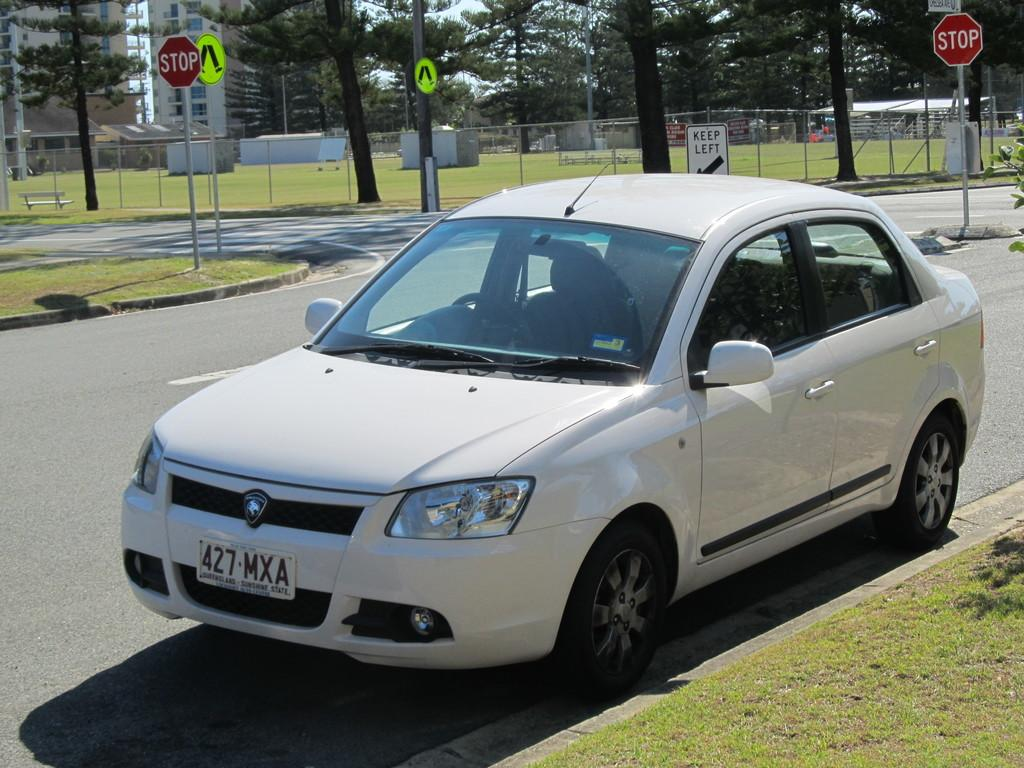What is placed on the road in the image? There is a car placed on the road in the image. What type of vegetation can be seen in the image? There is grass visible in the image, as well as a group of trees. What structures are present in the image? Signboards, a fence, a bench, and poles are present in the image. What is visible in the sky in the image? The sky is visible in the image and appears cloudy. What type of writing can be seen in the notebook on the bench in the image? There is no notebook or writing present in the image; it only features a car, grass, trees, signboards, a fence, a bench, poles, and a cloudy sky. 